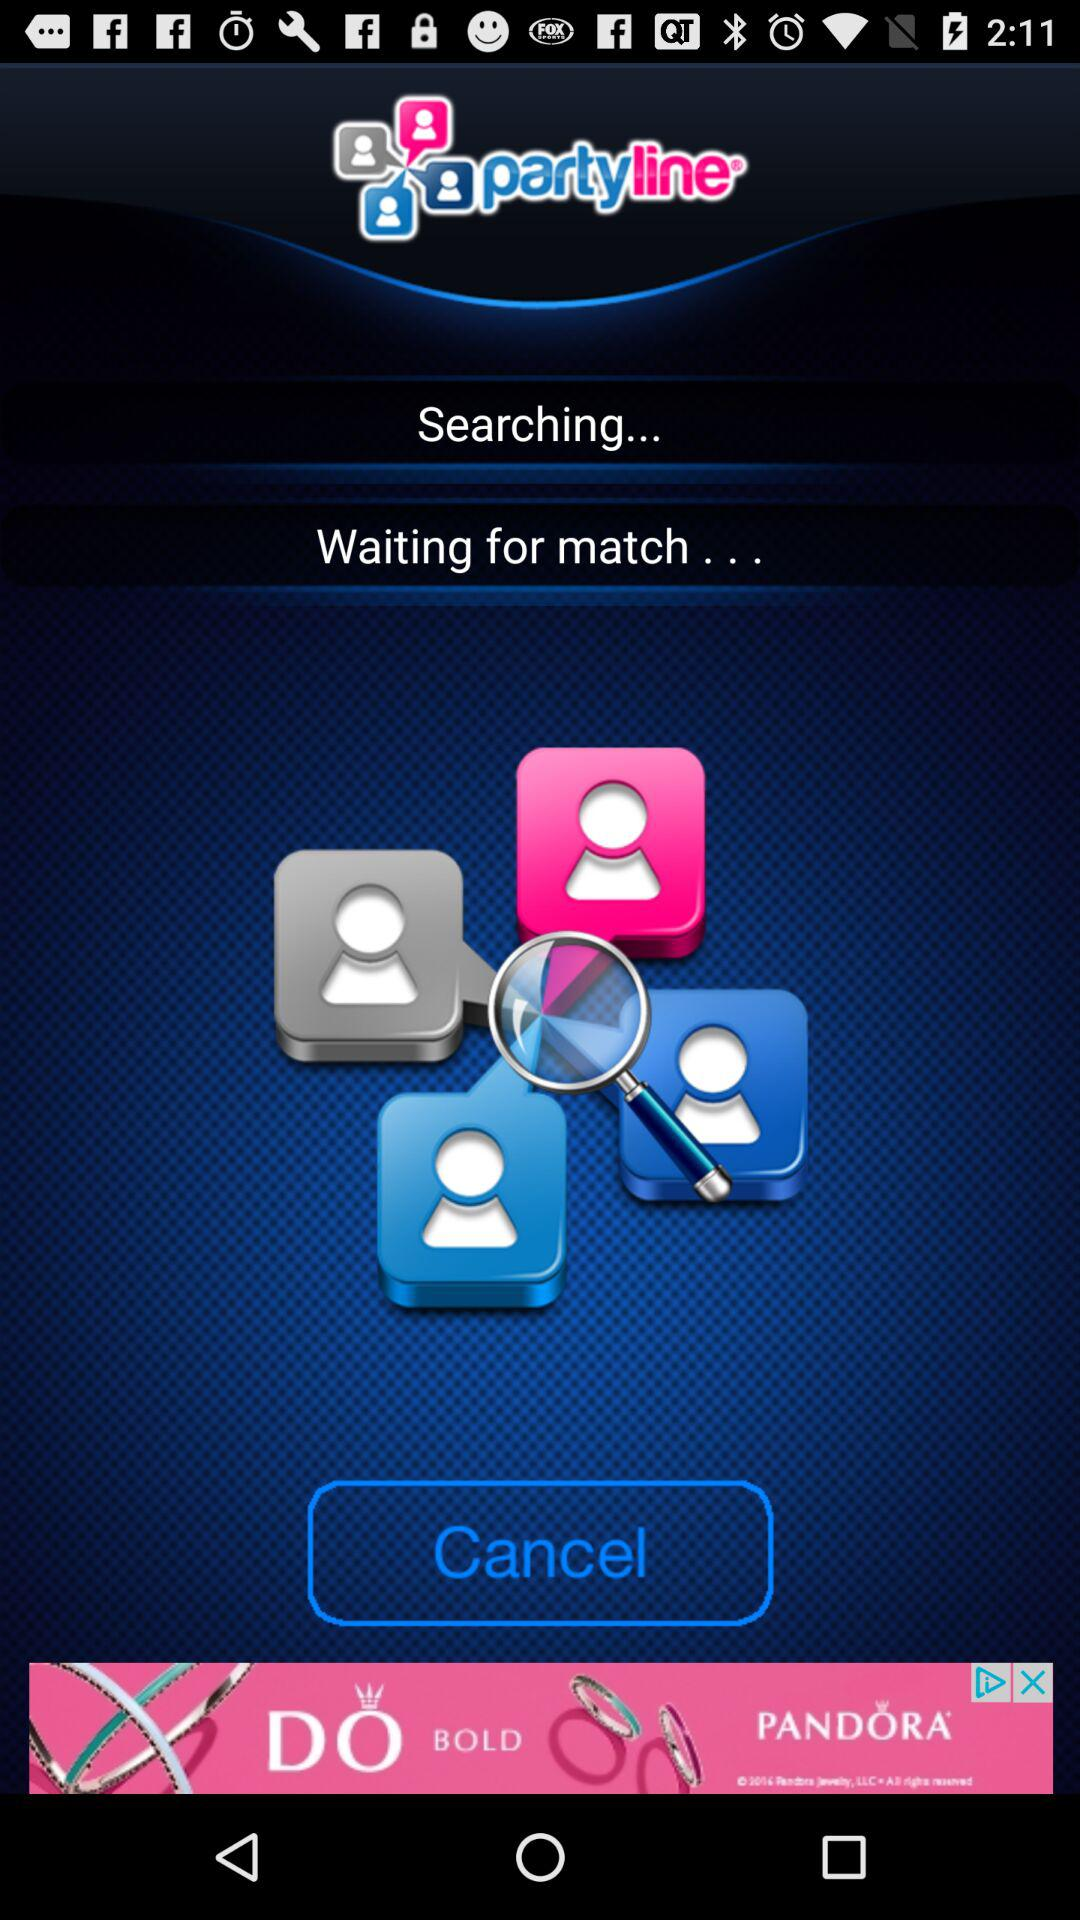What is the name of the application? The name of the application is "partyline". 